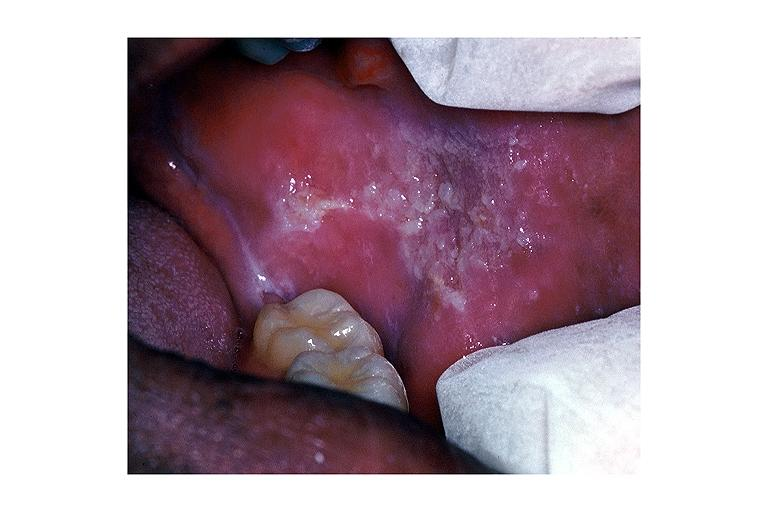does this image show leukoplakia?
Answer the question using a single word or phrase. Yes 